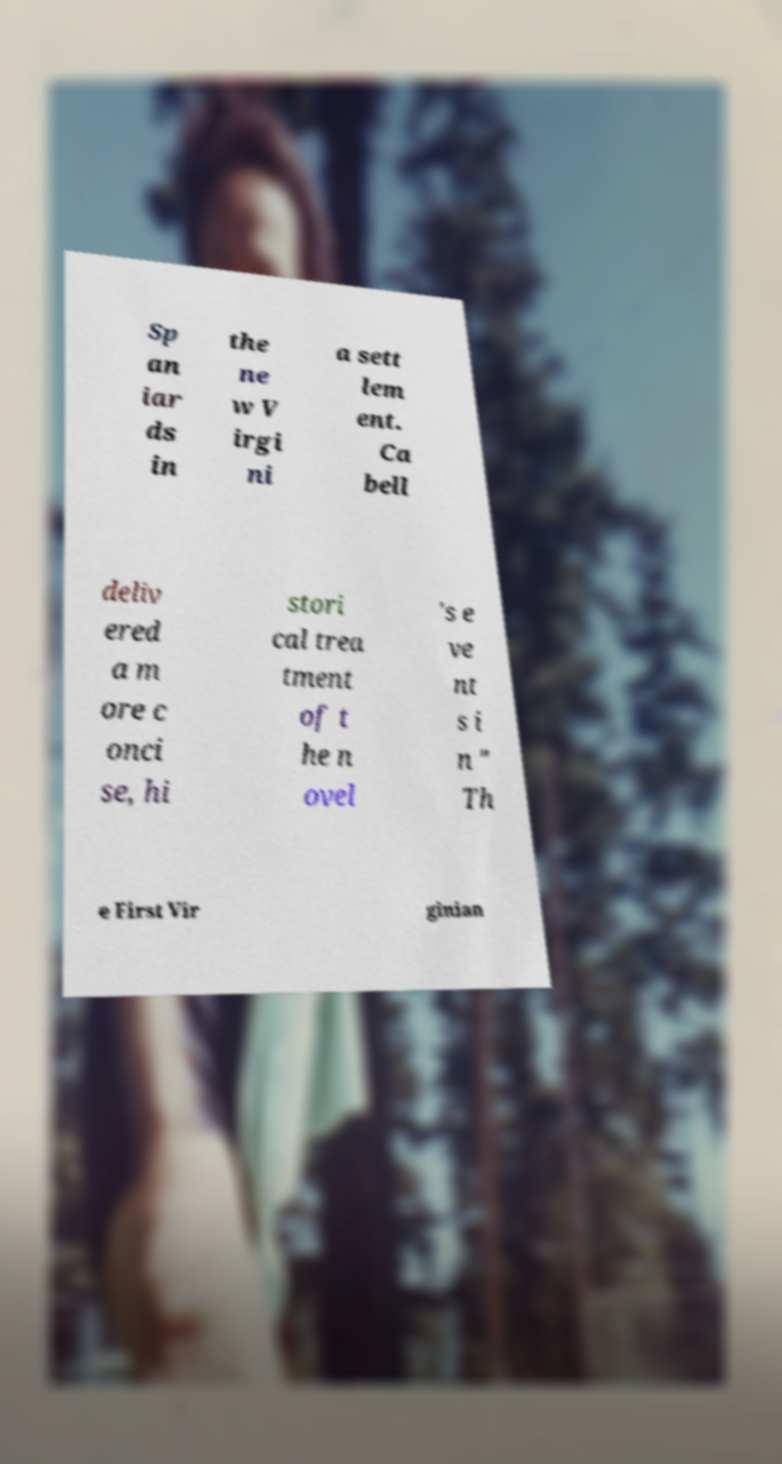Please identify and transcribe the text found in this image. Sp an iar ds in the ne w V irgi ni a sett lem ent. Ca bell deliv ered a m ore c onci se, hi stori cal trea tment of t he n ovel 's e ve nt s i n " Th e First Vir ginian 